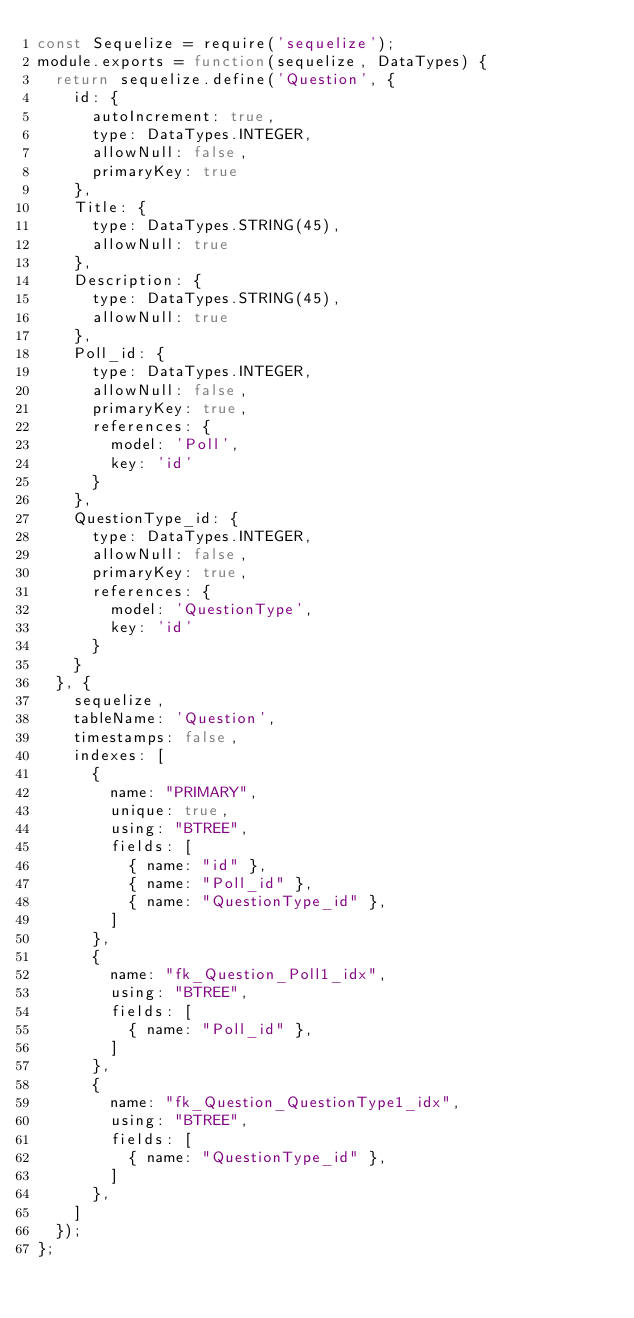<code> <loc_0><loc_0><loc_500><loc_500><_JavaScript_>const Sequelize = require('sequelize');
module.exports = function(sequelize, DataTypes) {
  return sequelize.define('Question', {
    id: {
      autoIncrement: true,
      type: DataTypes.INTEGER,
      allowNull: false,
      primaryKey: true
    },
    Title: {
      type: DataTypes.STRING(45),
      allowNull: true
    },
    Description: {
      type: DataTypes.STRING(45),
      allowNull: true
    },
    Poll_id: {
      type: DataTypes.INTEGER,
      allowNull: false,
      primaryKey: true,
      references: {
        model: 'Poll',
        key: 'id'
      }
    },
    QuestionType_id: {
      type: DataTypes.INTEGER,
      allowNull: false,
      primaryKey: true,
      references: {
        model: 'QuestionType',
        key: 'id'
      }
    }
  }, {
    sequelize,
    tableName: 'Question',
    timestamps: false,
    indexes: [
      {
        name: "PRIMARY",
        unique: true,
        using: "BTREE",
        fields: [
          { name: "id" },
          { name: "Poll_id" },
          { name: "QuestionType_id" },
        ]
      },
      {
        name: "fk_Question_Poll1_idx",
        using: "BTREE",
        fields: [
          { name: "Poll_id" },
        ]
      },
      {
        name: "fk_Question_QuestionType1_idx",
        using: "BTREE",
        fields: [
          { name: "QuestionType_id" },
        ]
      },
    ]
  });
};
</code> 